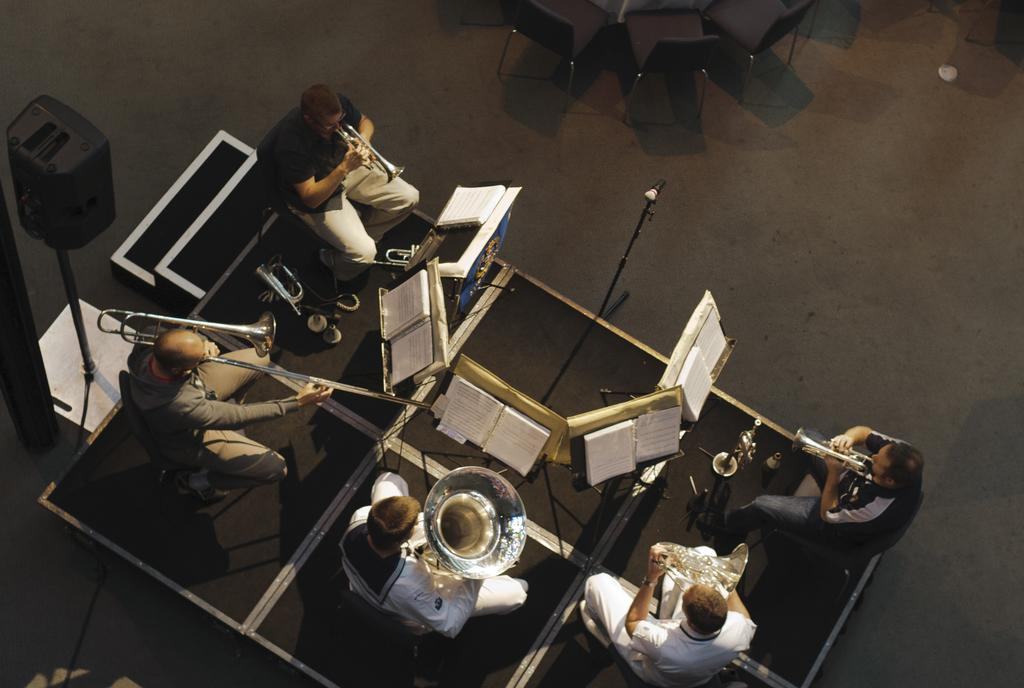What are the people in the image doing? People are playing musical instruments in the image. How are the musical instruments being held? The people are holding the musical instruments in their hands. What else can be seen in the image besides the people and musical instruments? There are books visible in the image, as well as a microphone and other objects on the floor. Can you see any cream on the cow in the image? There is no cow or cream present in the image. Is there a cactus growing in the middle of the room in the image? There is no cactus visible in the image. 